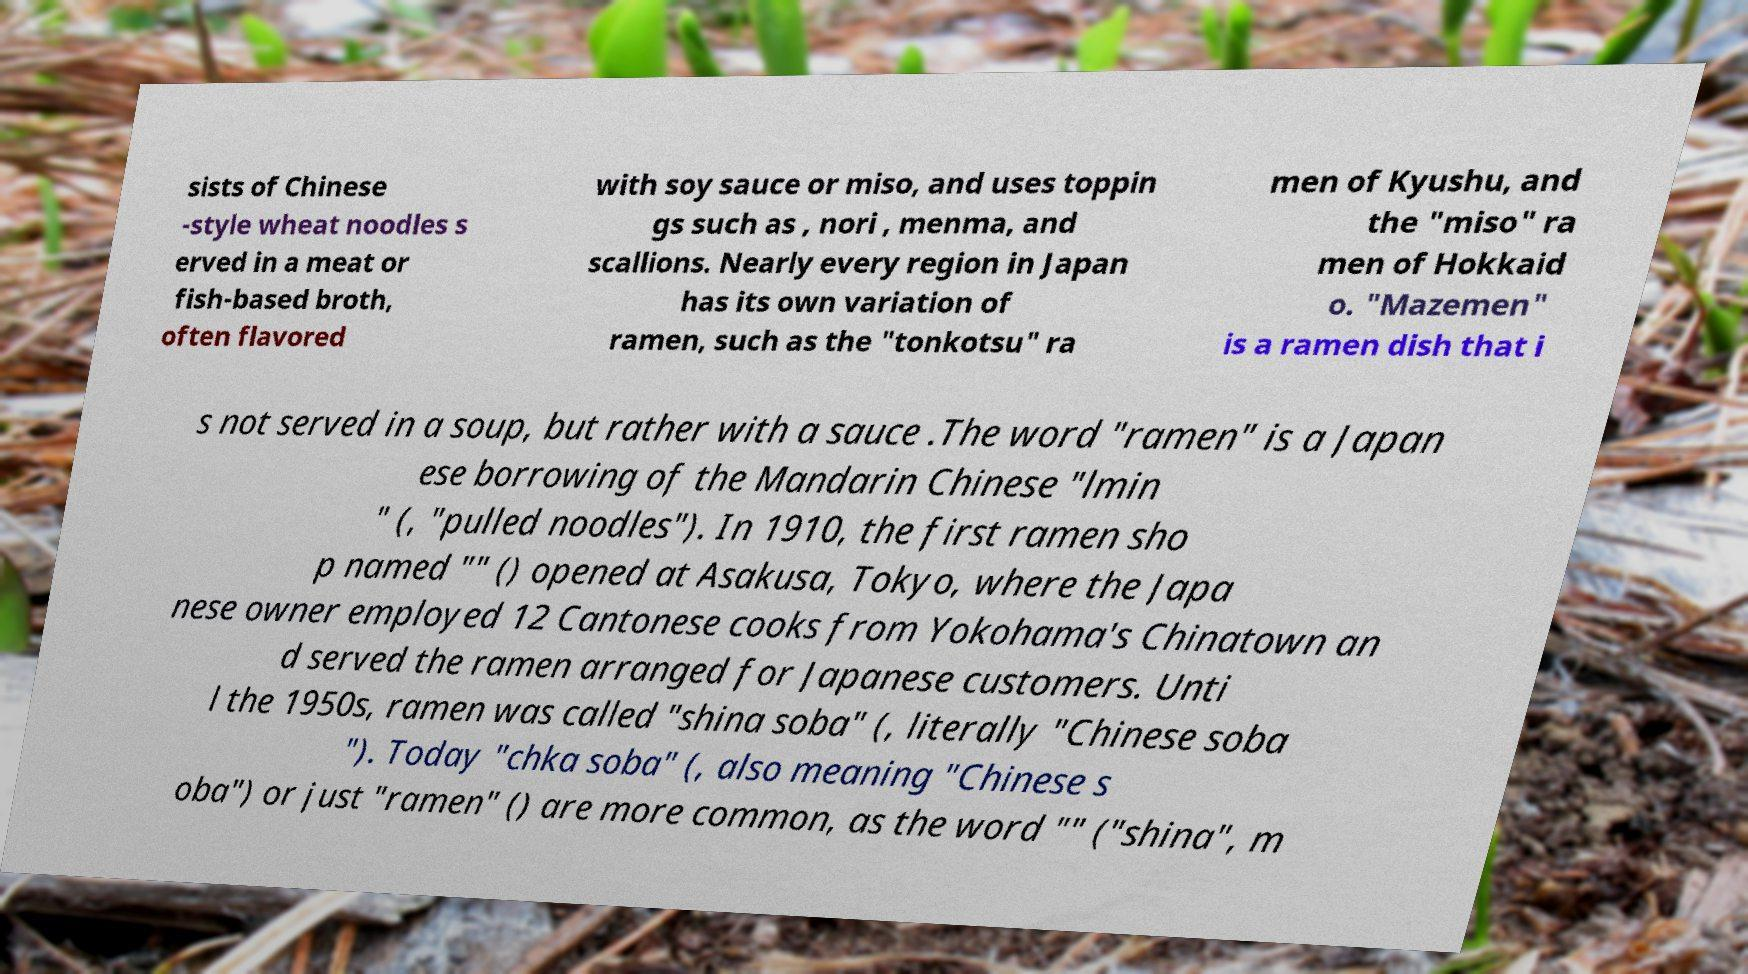Could you extract and type out the text from this image? sists of Chinese -style wheat noodles s erved in a meat or fish-based broth, often flavored with soy sauce or miso, and uses toppin gs such as , nori , menma, and scallions. Nearly every region in Japan has its own variation of ramen, such as the "tonkotsu" ra men of Kyushu, and the "miso" ra men of Hokkaid o. "Mazemen" is a ramen dish that i s not served in a soup, but rather with a sauce .The word "ramen" is a Japan ese borrowing of the Mandarin Chinese "lmin " (, "pulled noodles"). In 1910, the first ramen sho p named "" () opened at Asakusa, Tokyo, where the Japa nese owner employed 12 Cantonese cooks from Yokohama's Chinatown an d served the ramen arranged for Japanese customers. Unti l the 1950s, ramen was called "shina soba" (, literally "Chinese soba "). Today "chka soba" (, also meaning "Chinese s oba") or just "ramen" () are more common, as the word "" ("shina", m 